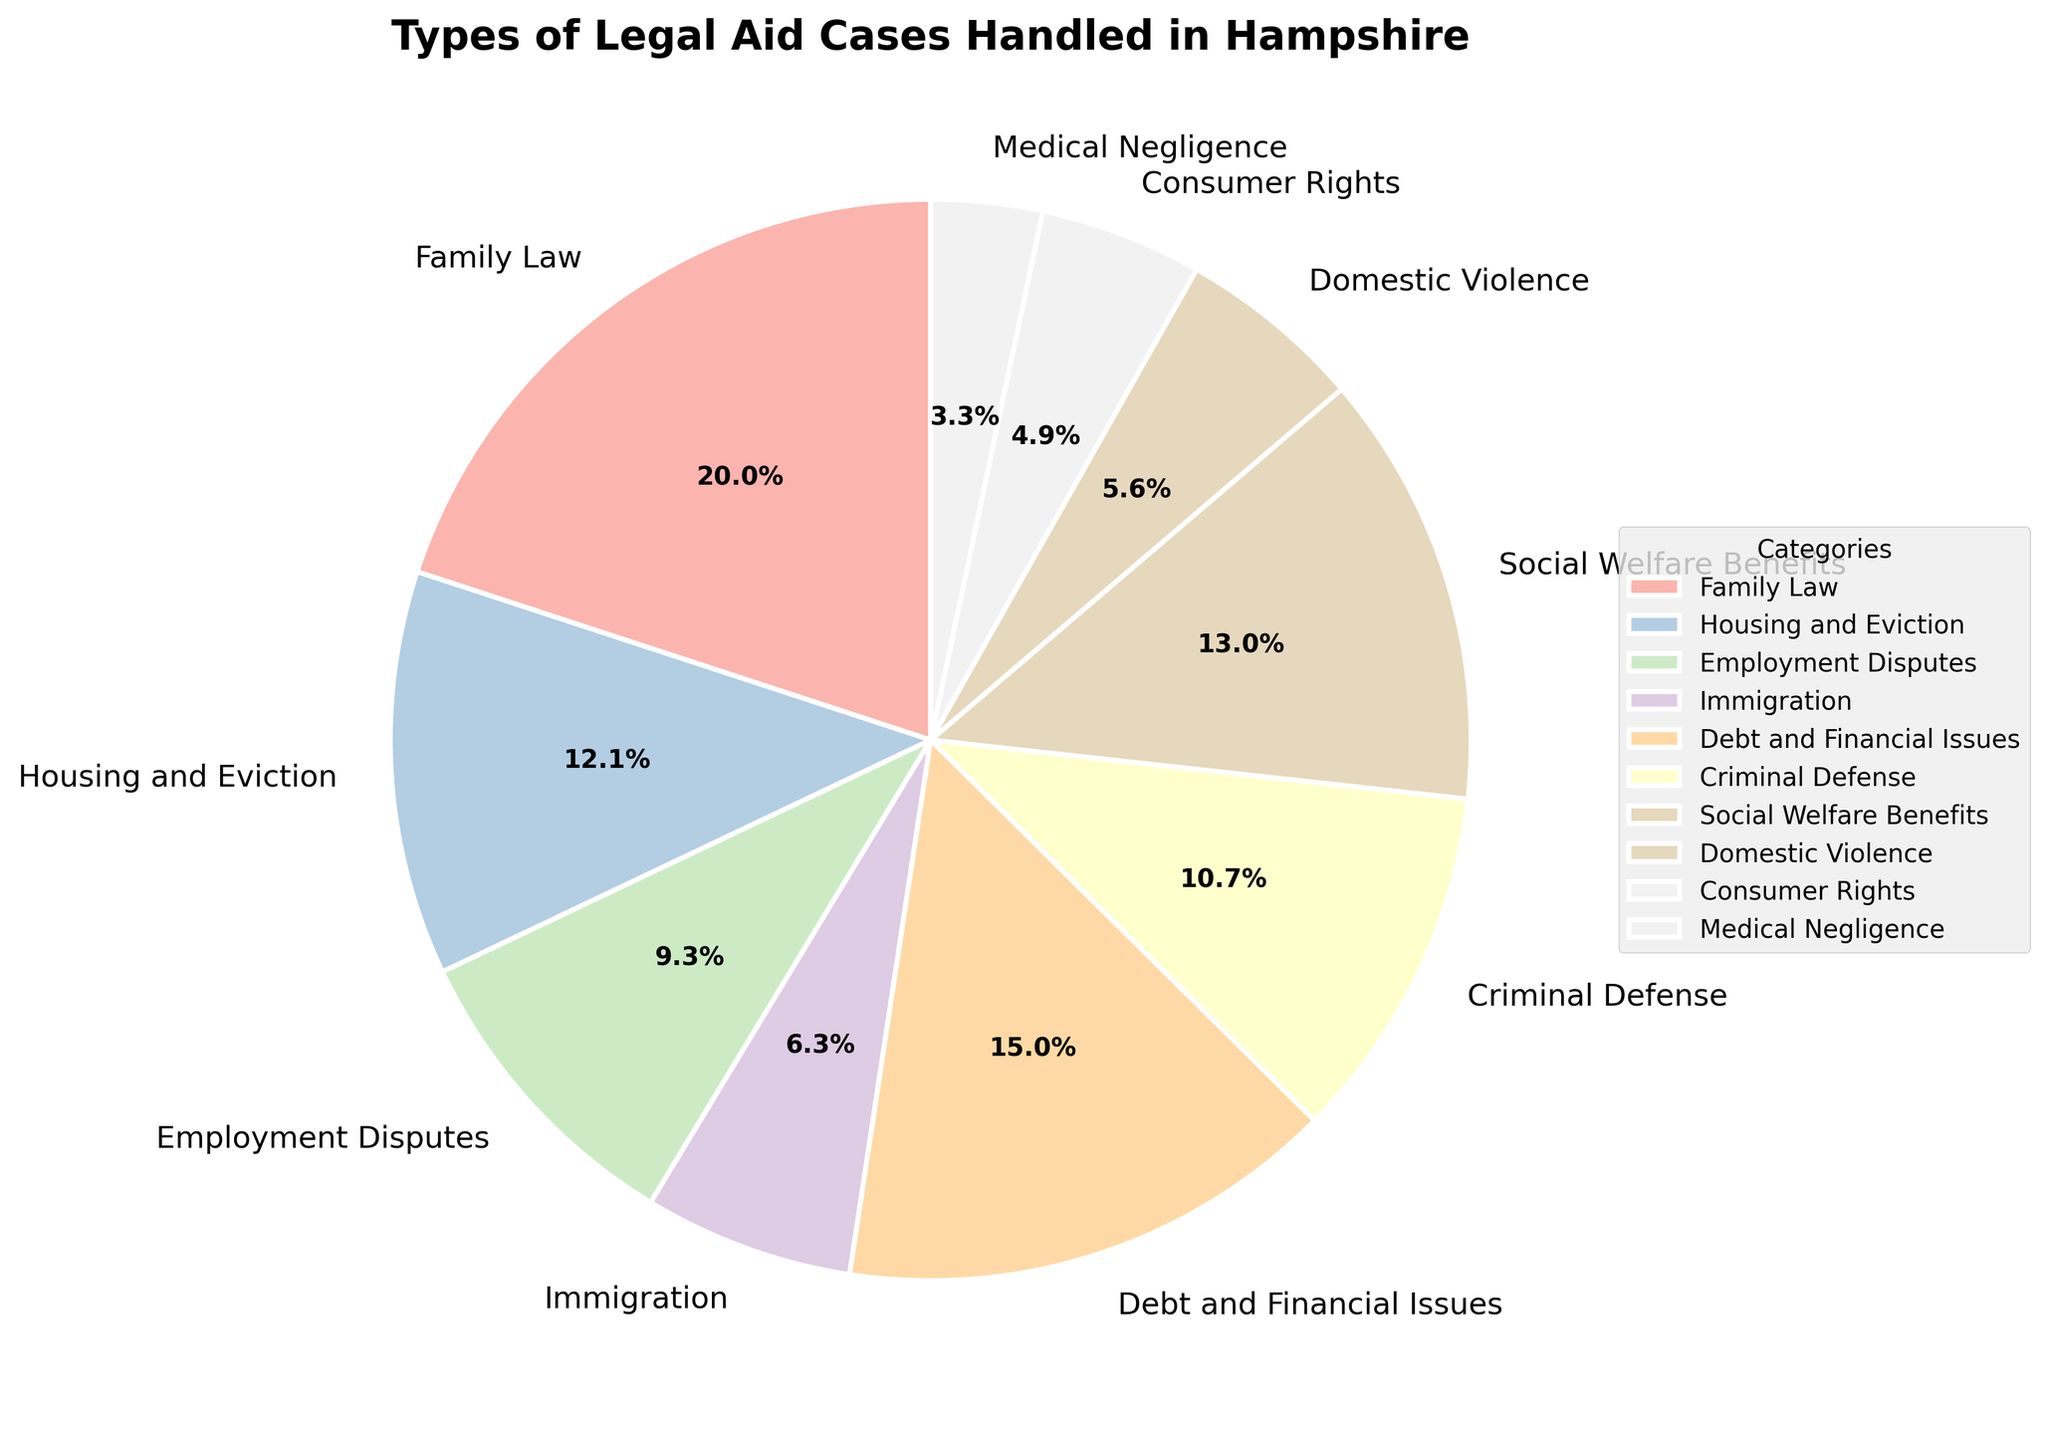Which category has the highest number of cases? Look at the categories in the pie chart and identify the one with the largest wedge. Here, Family Law is the largest wedge.
Answer: Family Law Which category has fewer cases: Domestic Violence or Consumer Rights? Compare the number of cases for Domestic Violence and Consumer Rights wedges in the pie chart. Domestic Violence has 87 cases, and Consumer Rights has 76 cases.
Answer: Consumer Rights What are the total cases for Housing and Eviction and Employment Disputes combined? Add the number of cases for Housing and Eviction (189) and Employment Disputes (145). 189 + 145 = 334
Answer: 334 Which category represents a higher percentage: Debt and Financial Issues or Social Welfare Benefits? Compare the size of the wedges and corresponding percentages of Debt and Financial Issues (12.8%) and Social Welfare Benefits (11.1%).
Answer: Debt and Financial Issues By how many cases does Immigration differ from Medical Negligence? Subtract the number of cases in Medical Negligence (52) from Immigration (98). 98 - 52 = 46
Answer: 46 How many total categories have more cases than Criminal Defense? Count the number of categories with a wedge size larger than Criminal Defense (167 cases). The categories are Family Law, Housing and Eviction, Debt and Financial Issues, and Social Welfare Benefits.
Answer: 4 What's the combined percentage of Family Law and Debt and Financial Issues? Add the percentages of Family Law (21.8%) and Debt and Financial Issues (16.3%) from the pie chart's visual. 21.8% + 16.3% = 38.1%
Answer: 38.1% What's the difference in the number of cases between the category with the most cases and the category with the least cases? Subtract the number of cases in the smallest category, Medical Negligence (52), from the largest category, Family Law (312). 312 - 52 = 260
Answer: 260 Which category falls exactly in the middle in terms of the number of cases? List the categories by the number of cases and find the median. Order: Medical Negligence, Consumer Rights, Domestic Violence, Immigration, Criminal Defense, Employment Disputes, Social Welfare Benefits, Debt and Financial Issues, Housing and Eviction, Family Law. The median is Immigration with 98 cases.
Answer: Immigration 